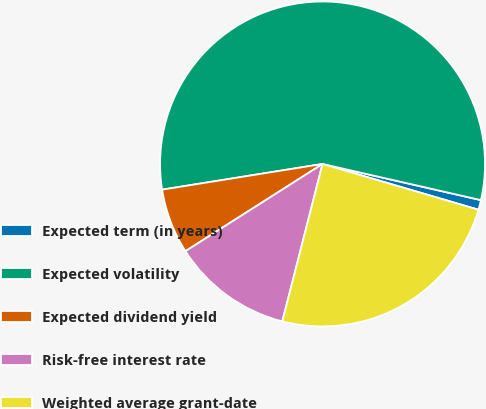Convert chart to OTSL. <chart><loc_0><loc_0><loc_500><loc_500><pie_chart><fcel>Expected term (in years)<fcel>Expected volatility<fcel>Expected dividend yield<fcel>Risk-free interest rate<fcel>Weighted average grant-date<nl><fcel>0.97%<fcel>56.1%<fcel>6.49%<fcel>12.0%<fcel>24.44%<nl></chart> 